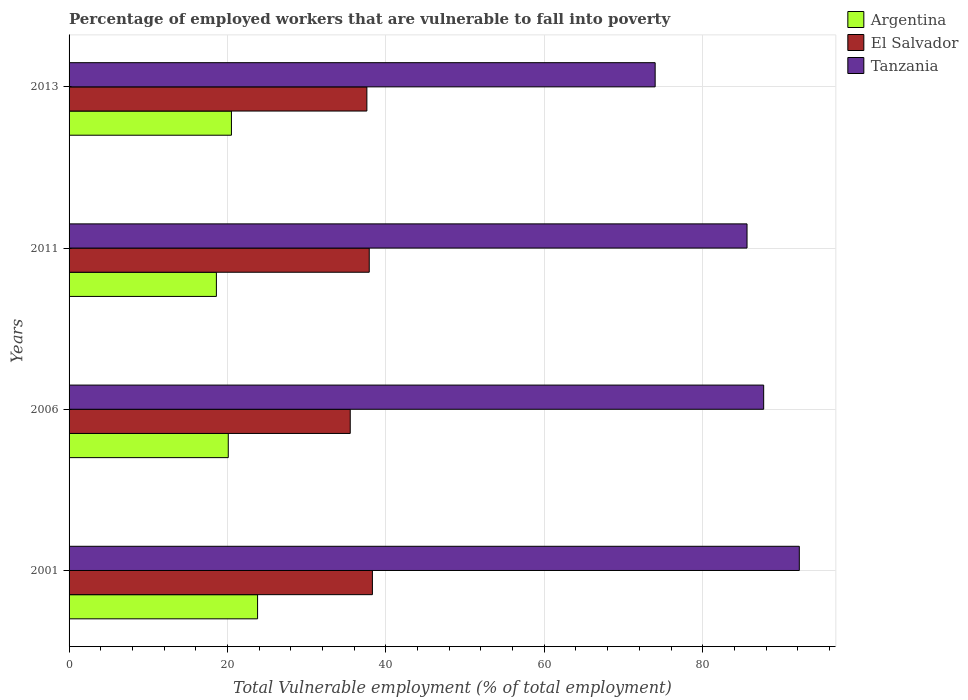How many different coloured bars are there?
Provide a succinct answer. 3. How many groups of bars are there?
Your answer should be compact. 4. Are the number of bars per tick equal to the number of legend labels?
Your answer should be compact. Yes. How many bars are there on the 2nd tick from the top?
Your answer should be very brief. 3. How many bars are there on the 2nd tick from the bottom?
Provide a succinct answer. 3. In how many cases, is the number of bars for a given year not equal to the number of legend labels?
Offer a very short reply. 0. What is the percentage of employed workers who are vulnerable to fall into poverty in Argentina in 2001?
Provide a succinct answer. 23.8. Across all years, what is the maximum percentage of employed workers who are vulnerable to fall into poverty in El Salvador?
Give a very brief answer. 38.3. Across all years, what is the minimum percentage of employed workers who are vulnerable to fall into poverty in Argentina?
Make the answer very short. 18.6. In which year was the percentage of employed workers who are vulnerable to fall into poverty in El Salvador minimum?
Your answer should be very brief. 2006. What is the total percentage of employed workers who are vulnerable to fall into poverty in Argentina in the graph?
Ensure brevity in your answer.  83. What is the difference between the percentage of employed workers who are vulnerable to fall into poverty in Argentina in 2001 and that in 2013?
Provide a short and direct response. 3.3. What is the difference between the percentage of employed workers who are vulnerable to fall into poverty in Tanzania in 2006 and the percentage of employed workers who are vulnerable to fall into poverty in Argentina in 2001?
Provide a succinct answer. 63.9. What is the average percentage of employed workers who are vulnerable to fall into poverty in El Salvador per year?
Offer a very short reply. 37.32. In the year 2006, what is the difference between the percentage of employed workers who are vulnerable to fall into poverty in Argentina and percentage of employed workers who are vulnerable to fall into poverty in El Salvador?
Provide a succinct answer. -15.4. What is the ratio of the percentage of employed workers who are vulnerable to fall into poverty in El Salvador in 2006 to that in 2011?
Give a very brief answer. 0.94. Is the difference between the percentage of employed workers who are vulnerable to fall into poverty in Argentina in 2001 and 2013 greater than the difference between the percentage of employed workers who are vulnerable to fall into poverty in El Salvador in 2001 and 2013?
Your answer should be compact. Yes. What is the difference between the highest and the second highest percentage of employed workers who are vulnerable to fall into poverty in Argentina?
Offer a very short reply. 3.3. What is the difference between the highest and the lowest percentage of employed workers who are vulnerable to fall into poverty in Tanzania?
Ensure brevity in your answer.  18.2. What does the 3rd bar from the bottom in 2011 represents?
Your response must be concise. Tanzania. How many bars are there?
Your answer should be compact. 12. How many years are there in the graph?
Provide a short and direct response. 4. Are the values on the major ticks of X-axis written in scientific E-notation?
Your answer should be very brief. No. Does the graph contain any zero values?
Give a very brief answer. No. How many legend labels are there?
Keep it short and to the point. 3. What is the title of the graph?
Offer a terse response. Percentage of employed workers that are vulnerable to fall into poverty. What is the label or title of the X-axis?
Your answer should be compact. Total Vulnerable employment (% of total employment). What is the label or title of the Y-axis?
Provide a succinct answer. Years. What is the Total Vulnerable employment (% of total employment) of Argentina in 2001?
Give a very brief answer. 23.8. What is the Total Vulnerable employment (% of total employment) in El Salvador in 2001?
Ensure brevity in your answer.  38.3. What is the Total Vulnerable employment (% of total employment) in Tanzania in 2001?
Provide a short and direct response. 92.2. What is the Total Vulnerable employment (% of total employment) in Argentina in 2006?
Make the answer very short. 20.1. What is the Total Vulnerable employment (% of total employment) of El Salvador in 2006?
Offer a terse response. 35.5. What is the Total Vulnerable employment (% of total employment) in Tanzania in 2006?
Your answer should be very brief. 87.7. What is the Total Vulnerable employment (% of total employment) of Argentina in 2011?
Ensure brevity in your answer.  18.6. What is the Total Vulnerable employment (% of total employment) in El Salvador in 2011?
Make the answer very short. 37.9. What is the Total Vulnerable employment (% of total employment) in Tanzania in 2011?
Offer a terse response. 85.6. What is the Total Vulnerable employment (% of total employment) of Argentina in 2013?
Your answer should be compact. 20.5. What is the Total Vulnerable employment (% of total employment) of El Salvador in 2013?
Make the answer very short. 37.6. Across all years, what is the maximum Total Vulnerable employment (% of total employment) in Argentina?
Offer a very short reply. 23.8. Across all years, what is the maximum Total Vulnerable employment (% of total employment) of El Salvador?
Provide a short and direct response. 38.3. Across all years, what is the maximum Total Vulnerable employment (% of total employment) of Tanzania?
Your answer should be very brief. 92.2. Across all years, what is the minimum Total Vulnerable employment (% of total employment) of Argentina?
Offer a very short reply. 18.6. Across all years, what is the minimum Total Vulnerable employment (% of total employment) of El Salvador?
Offer a very short reply. 35.5. Across all years, what is the minimum Total Vulnerable employment (% of total employment) of Tanzania?
Your answer should be very brief. 74. What is the total Total Vulnerable employment (% of total employment) of El Salvador in the graph?
Ensure brevity in your answer.  149.3. What is the total Total Vulnerable employment (% of total employment) of Tanzania in the graph?
Provide a succinct answer. 339.5. What is the difference between the Total Vulnerable employment (% of total employment) in Argentina in 2001 and that in 2006?
Ensure brevity in your answer.  3.7. What is the difference between the Total Vulnerable employment (% of total employment) of El Salvador in 2001 and that in 2006?
Ensure brevity in your answer.  2.8. What is the difference between the Total Vulnerable employment (% of total employment) of Tanzania in 2001 and that in 2006?
Provide a succinct answer. 4.5. What is the difference between the Total Vulnerable employment (% of total employment) in Argentina in 2001 and that in 2011?
Your answer should be very brief. 5.2. What is the difference between the Total Vulnerable employment (% of total employment) in Tanzania in 2001 and that in 2011?
Your answer should be very brief. 6.6. What is the difference between the Total Vulnerable employment (% of total employment) of Argentina in 2001 and that in 2013?
Give a very brief answer. 3.3. What is the difference between the Total Vulnerable employment (% of total employment) in Tanzania in 2006 and that in 2011?
Your answer should be compact. 2.1. What is the difference between the Total Vulnerable employment (% of total employment) in Argentina in 2006 and that in 2013?
Give a very brief answer. -0.4. What is the difference between the Total Vulnerable employment (% of total employment) in Argentina in 2011 and that in 2013?
Keep it short and to the point. -1.9. What is the difference between the Total Vulnerable employment (% of total employment) in El Salvador in 2011 and that in 2013?
Your answer should be very brief. 0.3. What is the difference between the Total Vulnerable employment (% of total employment) in Tanzania in 2011 and that in 2013?
Offer a terse response. 11.6. What is the difference between the Total Vulnerable employment (% of total employment) of Argentina in 2001 and the Total Vulnerable employment (% of total employment) of El Salvador in 2006?
Offer a terse response. -11.7. What is the difference between the Total Vulnerable employment (% of total employment) of Argentina in 2001 and the Total Vulnerable employment (% of total employment) of Tanzania in 2006?
Ensure brevity in your answer.  -63.9. What is the difference between the Total Vulnerable employment (% of total employment) of El Salvador in 2001 and the Total Vulnerable employment (% of total employment) of Tanzania in 2006?
Ensure brevity in your answer.  -49.4. What is the difference between the Total Vulnerable employment (% of total employment) of Argentina in 2001 and the Total Vulnerable employment (% of total employment) of El Salvador in 2011?
Provide a short and direct response. -14.1. What is the difference between the Total Vulnerable employment (% of total employment) of Argentina in 2001 and the Total Vulnerable employment (% of total employment) of Tanzania in 2011?
Provide a short and direct response. -61.8. What is the difference between the Total Vulnerable employment (% of total employment) in El Salvador in 2001 and the Total Vulnerable employment (% of total employment) in Tanzania in 2011?
Offer a very short reply. -47.3. What is the difference between the Total Vulnerable employment (% of total employment) in Argentina in 2001 and the Total Vulnerable employment (% of total employment) in Tanzania in 2013?
Provide a succinct answer. -50.2. What is the difference between the Total Vulnerable employment (% of total employment) in El Salvador in 2001 and the Total Vulnerable employment (% of total employment) in Tanzania in 2013?
Your response must be concise. -35.7. What is the difference between the Total Vulnerable employment (% of total employment) in Argentina in 2006 and the Total Vulnerable employment (% of total employment) in El Salvador in 2011?
Make the answer very short. -17.8. What is the difference between the Total Vulnerable employment (% of total employment) in Argentina in 2006 and the Total Vulnerable employment (% of total employment) in Tanzania in 2011?
Your response must be concise. -65.5. What is the difference between the Total Vulnerable employment (% of total employment) in El Salvador in 2006 and the Total Vulnerable employment (% of total employment) in Tanzania in 2011?
Provide a short and direct response. -50.1. What is the difference between the Total Vulnerable employment (% of total employment) of Argentina in 2006 and the Total Vulnerable employment (% of total employment) of El Salvador in 2013?
Provide a succinct answer. -17.5. What is the difference between the Total Vulnerable employment (% of total employment) in Argentina in 2006 and the Total Vulnerable employment (% of total employment) in Tanzania in 2013?
Keep it short and to the point. -53.9. What is the difference between the Total Vulnerable employment (% of total employment) of El Salvador in 2006 and the Total Vulnerable employment (% of total employment) of Tanzania in 2013?
Offer a very short reply. -38.5. What is the difference between the Total Vulnerable employment (% of total employment) in Argentina in 2011 and the Total Vulnerable employment (% of total employment) in Tanzania in 2013?
Offer a terse response. -55.4. What is the difference between the Total Vulnerable employment (% of total employment) in El Salvador in 2011 and the Total Vulnerable employment (% of total employment) in Tanzania in 2013?
Your answer should be compact. -36.1. What is the average Total Vulnerable employment (% of total employment) in Argentina per year?
Provide a succinct answer. 20.75. What is the average Total Vulnerable employment (% of total employment) of El Salvador per year?
Offer a very short reply. 37.33. What is the average Total Vulnerable employment (% of total employment) of Tanzania per year?
Ensure brevity in your answer.  84.88. In the year 2001, what is the difference between the Total Vulnerable employment (% of total employment) of Argentina and Total Vulnerable employment (% of total employment) of Tanzania?
Offer a terse response. -68.4. In the year 2001, what is the difference between the Total Vulnerable employment (% of total employment) of El Salvador and Total Vulnerable employment (% of total employment) of Tanzania?
Keep it short and to the point. -53.9. In the year 2006, what is the difference between the Total Vulnerable employment (% of total employment) in Argentina and Total Vulnerable employment (% of total employment) in El Salvador?
Provide a succinct answer. -15.4. In the year 2006, what is the difference between the Total Vulnerable employment (% of total employment) in Argentina and Total Vulnerable employment (% of total employment) in Tanzania?
Your answer should be compact. -67.6. In the year 2006, what is the difference between the Total Vulnerable employment (% of total employment) of El Salvador and Total Vulnerable employment (% of total employment) of Tanzania?
Provide a succinct answer. -52.2. In the year 2011, what is the difference between the Total Vulnerable employment (% of total employment) of Argentina and Total Vulnerable employment (% of total employment) of El Salvador?
Give a very brief answer. -19.3. In the year 2011, what is the difference between the Total Vulnerable employment (% of total employment) of Argentina and Total Vulnerable employment (% of total employment) of Tanzania?
Give a very brief answer. -67. In the year 2011, what is the difference between the Total Vulnerable employment (% of total employment) of El Salvador and Total Vulnerable employment (% of total employment) of Tanzania?
Offer a very short reply. -47.7. In the year 2013, what is the difference between the Total Vulnerable employment (% of total employment) of Argentina and Total Vulnerable employment (% of total employment) of El Salvador?
Your answer should be very brief. -17.1. In the year 2013, what is the difference between the Total Vulnerable employment (% of total employment) in Argentina and Total Vulnerable employment (% of total employment) in Tanzania?
Your answer should be compact. -53.5. In the year 2013, what is the difference between the Total Vulnerable employment (% of total employment) in El Salvador and Total Vulnerable employment (% of total employment) in Tanzania?
Offer a terse response. -36.4. What is the ratio of the Total Vulnerable employment (% of total employment) of Argentina in 2001 to that in 2006?
Make the answer very short. 1.18. What is the ratio of the Total Vulnerable employment (% of total employment) of El Salvador in 2001 to that in 2006?
Offer a very short reply. 1.08. What is the ratio of the Total Vulnerable employment (% of total employment) of Tanzania in 2001 to that in 2006?
Your answer should be very brief. 1.05. What is the ratio of the Total Vulnerable employment (% of total employment) of Argentina in 2001 to that in 2011?
Your answer should be very brief. 1.28. What is the ratio of the Total Vulnerable employment (% of total employment) in El Salvador in 2001 to that in 2011?
Offer a terse response. 1.01. What is the ratio of the Total Vulnerable employment (% of total employment) of Tanzania in 2001 to that in 2011?
Ensure brevity in your answer.  1.08. What is the ratio of the Total Vulnerable employment (% of total employment) of Argentina in 2001 to that in 2013?
Provide a short and direct response. 1.16. What is the ratio of the Total Vulnerable employment (% of total employment) of El Salvador in 2001 to that in 2013?
Make the answer very short. 1.02. What is the ratio of the Total Vulnerable employment (% of total employment) in Tanzania in 2001 to that in 2013?
Your answer should be very brief. 1.25. What is the ratio of the Total Vulnerable employment (% of total employment) of Argentina in 2006 to that in 2011?
Keep it short and to the point. 1.08. What is the ratio of the Total Vulnerable employment (% of total employment) of El Salvador in 2006 to that in 2011?
Your response must be concise. 0.94. What is the ratio of the Total Vulnerable employment (% of total employment) in Tanzania in 2006 to that in 2011?
Offer a very short reply. 1.02. What is the ratio of the Total Vulnerable employment (% of total employment) in Argentina in 2006 to that in 2013?
Make the answer very short. 0.98. What is the ratio of the Total Vulnerable employment (% of total employment) in El Salvador in 2006 to that in 2013?
Your answer should be very brief. 0.94. What is the ratio of the Total Vulnerable employment (% of total employment) in Tanzania in 2006 to that in 2013?
Offer a very short reply. 1.19. What is the ratio of the Total Vulnerable employment (% of total employment) of Argentina in 2011 to that in 2013?
Provide a succinct answer. 0.91. What is the ratio of the Total Vulnerable employment (% of total employment) of El Salvador in 2011 to that in 2013?
Give a very brief answer. 1.01. What is the ratio of the Total Vulnerable employment (% of total employment) in Tanzania in 2011 to that in 2013?
Make the answer very short. 1.16. What is the difference between the highest and the second highest Total Vulnerable employment (% of total employment) in El Salvador?
Provide a succinct answer. 0.4. What is the difference between the highest and the second highest Total Vulnerable employment (% of total employment) in Tanzania?
Give a very brief answer. 4.5. What is the difference between the highest and the lowest Total Vulnerable employment (% of total employment) in El Salvador?
Offer a terse response. 2.8. What is the difference between the highest and the lowest Total Vulnerable employment (% of total employment) of Tanzania?
Provide a short and direct response. 18.2. 